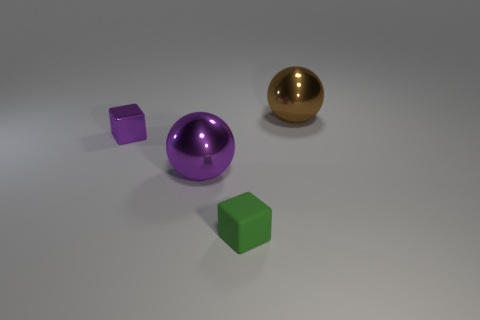Are there any other things that are made of the same material as the small green thing?
Ensure brevity in your answer.  No. There is a green object that is the same size as the shiny block; what material is it?
Keep it short and to the point. Rubber. Is the number of yellow metallic balls greater than the number of green things?
Keep it short and to the point. No. There is a purple object behind the metallic sphere in front of the brown ball; what size is it?
Your answer should be very brief. Small. There is a matte object that is the same size as the purple block; what shape is it?
Your answer should be compact. Cube. What shape is the large thing that is right of the purple metal thing in front of the block behind the purple sphere?
Your response must be concise. Sphere. Do the tiny metal thing that is left of the brown ball and the large metal sphere that is on the left side of the green cube have the same color?
Your response must be concise. Yes. How many green balls are there?
Offer a terse response. 0. Are there any objects on the right side of the rubber block?
Offer a terse response. Yes. Is the cube to the left of the tiny matte block made of the same material as the small cube in front of the small purple block?
Your answer should be very brief. No. 